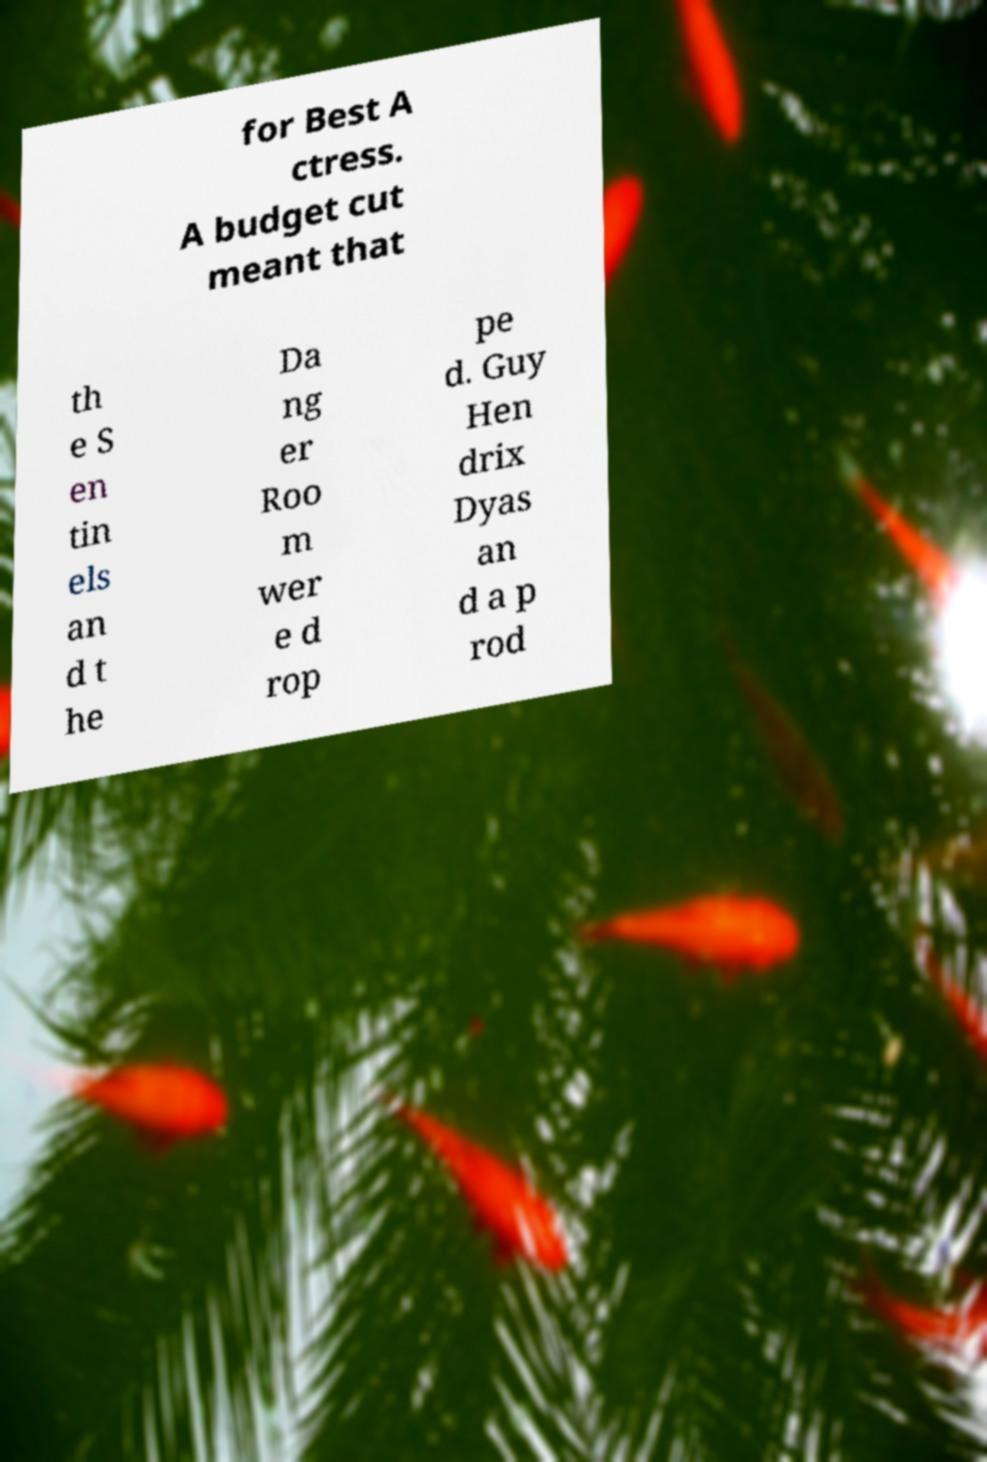Please read and relay the text visible in this image. What does it say? for Best A ctress. A budget cut meant that th e S en tin els an d t he Da ng er Roo m wer e d rop pe d. Guy Hen drix Dyas an d a p rod 